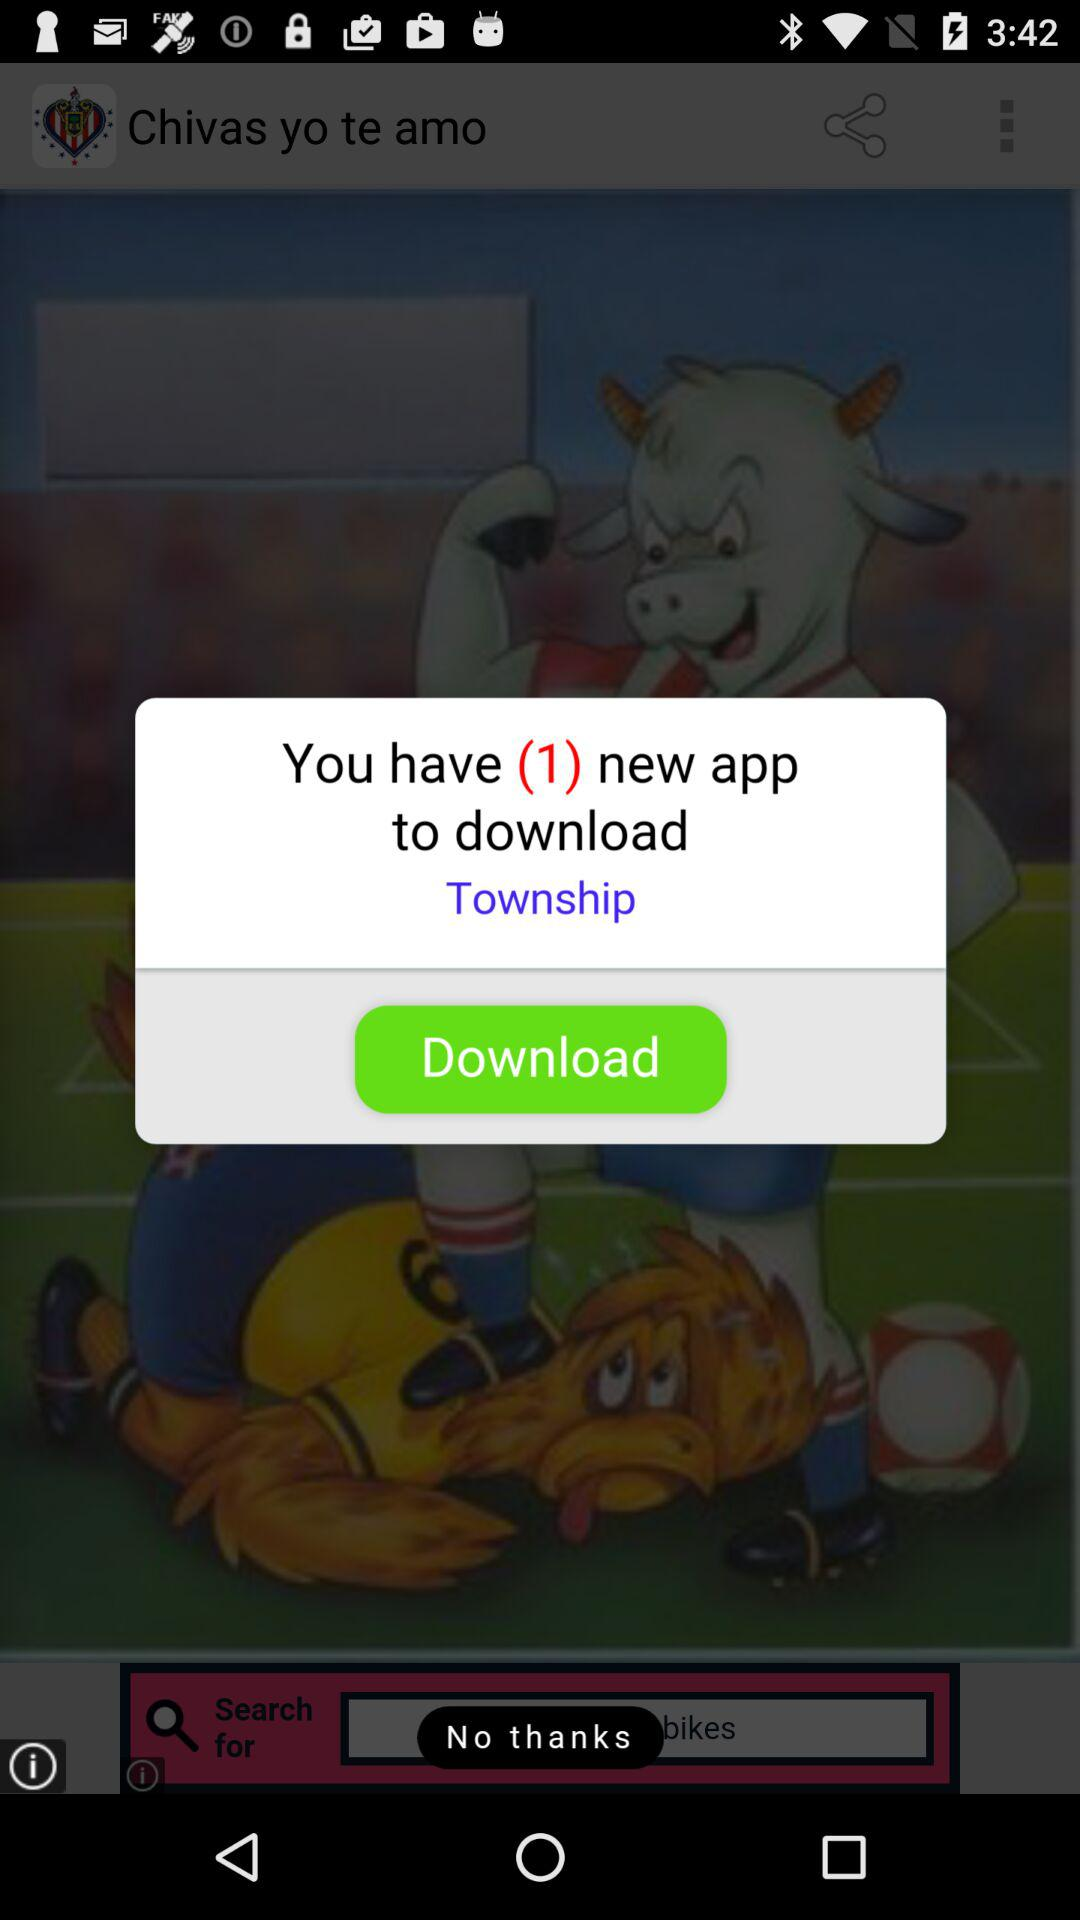How many apps do I have to download?
Answer the question using a single word or phrase. 1 